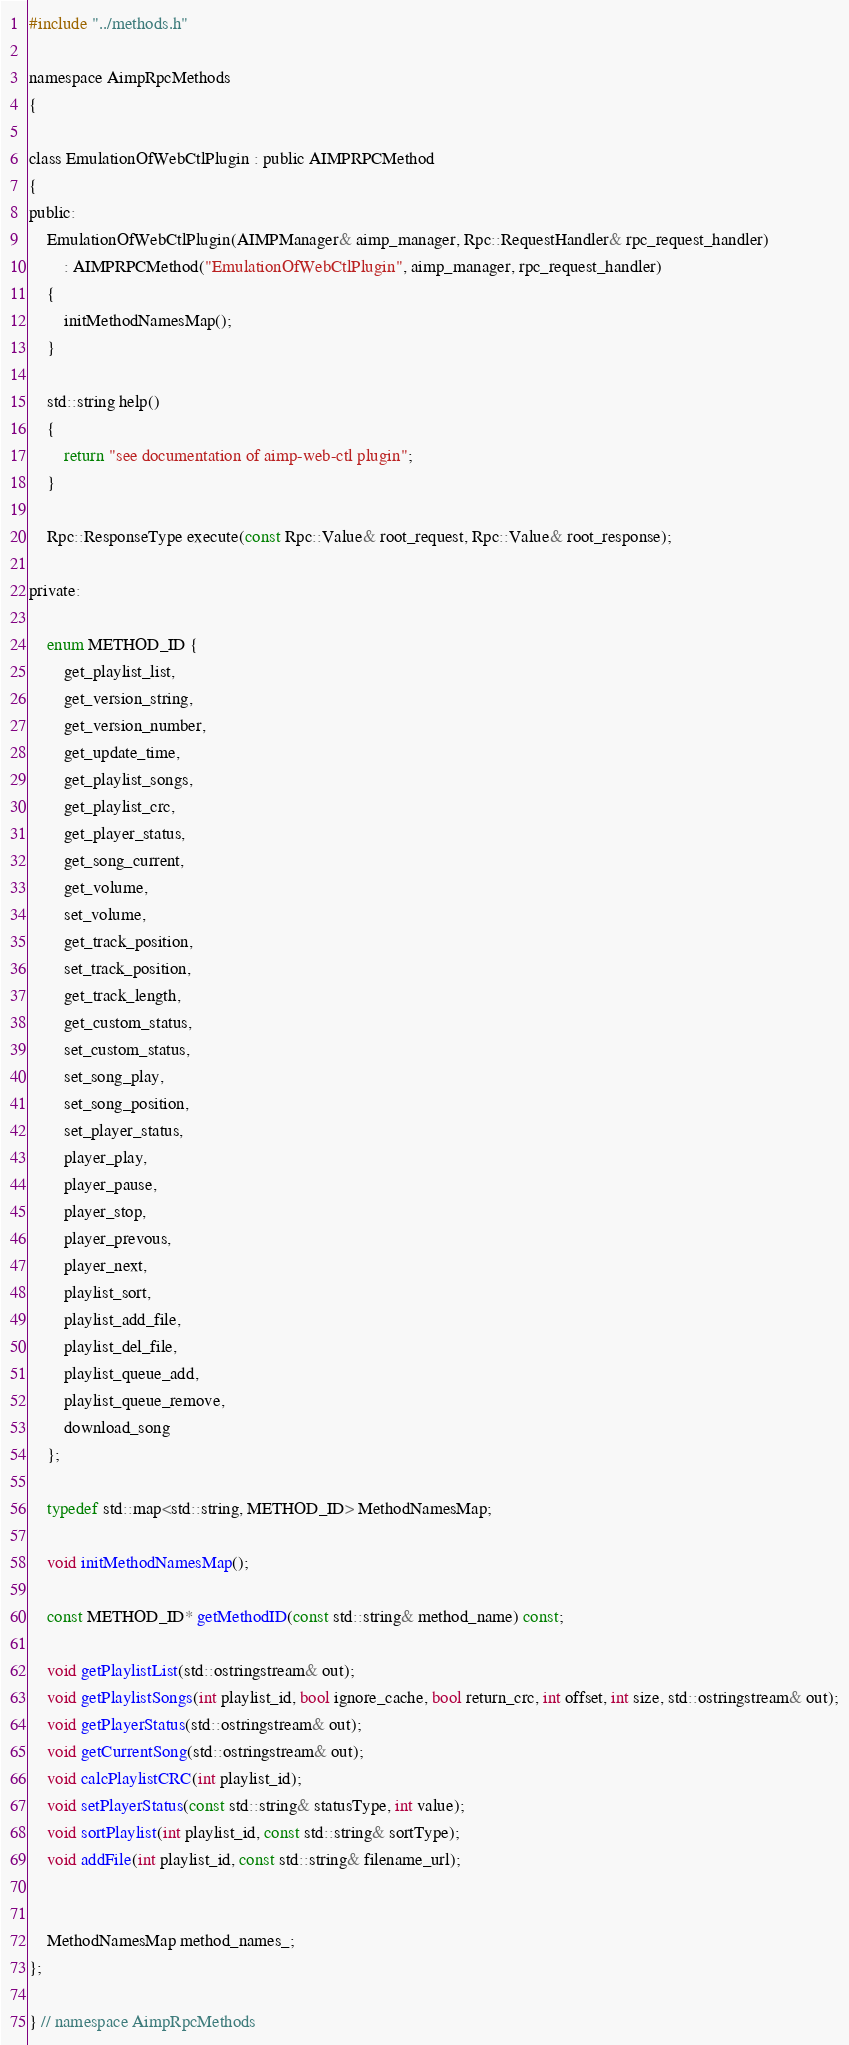Convert code to text. <code><loc_0><loc_0><loc_500><loc_500><_C_>#include "../methods.h"

namespace AimpRpcMethods
{

class EmulationOfWebCtlPlugin : public AIMPRPCMethod
{
public:
    EmulationOfWebCtlPlugin(AIMPManager& aimp_manager, Rpc::RequestHandler& rpc_request_handler)
        : AIMPRPCMethod("EmulationOfWebCtlPlugin", aimp_manager, rpc_request_handler)
    {
        initMethodNamesMap();
    }

    std::string help()
    {
        return "see documentation of aimp-web-ctl plugin";
    }

    Rpc::ResponseType execute(const Rpc::Value& root_request, Rpc::Value& root_response);

private:

    enum METHOD_ID {
        get_playlist_list,
        get_version_string,
        get_version_number,
        get_update_time,
        get_playlist_songs,
        get_playlist_crc,
        get_player_status,
        get_song_current,
        get_volume,
        set_volume,
        get_track_position,
        set_track_position,
        get_track_length,
        get_custom_status,
        set_custom_status,
        set_song_play,
        set_song_position,
        set_player_status,
        player_play,
        player_pause,
        player_stop,
        player_prevous,
        player_next,
        playlist_sort,
        playlist_add_file,
        playlist_del_file,
        playlist_queue_add,
        playlist_queue_remove,
        download_song
    };

    typedef std::map<std::string, METHOD_ID> MethodNamesMap;

    void initMethodNamesMap();

    const METHOD_ID* getMethodID(const std::string& method_name) const;

    void getPlaylistList(std::ostringstream& out);
    void getPlaylistSongs(int playlist_id, bool ignore_cache, bool return_crc, int offset, int size, std::ostringstream& out);
    void getPlayerStatus(std::ostringstream& out);
    void getCurrentSong(std::ostringstream& out);
    void calcPlaylistCRC(int playlist_id);
    void setPlayerStatus(const std::string& statusType, int value);
    void sortPlaylist(int playlist_id, const std::string& sortType);
    void addFile(int playlist_id, const std::string& filename_url);


    MethodNamesMap method_names_;
};

} // namespace AimpRpcMethods
</code> 